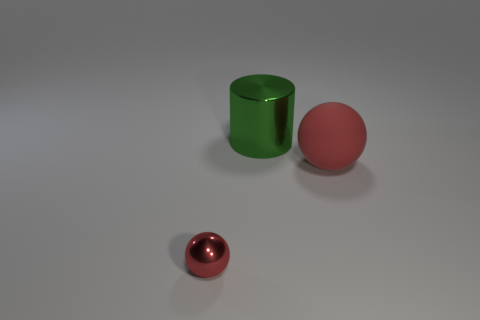Add 2 large red matte spheres. How many objects exist? 5 Subtract all balls. How many objects are left? 1 Add 1 tiny cyan shiny things. How many tiny cyan shiny things exist? 1 Subtract 0 yellow cubes. How many objects are left? 3 Subtract all big blue matte spheres. Subtract all red spheres. How many objects are left? 1 Add 3 large objects. How many large objects are left? 5 